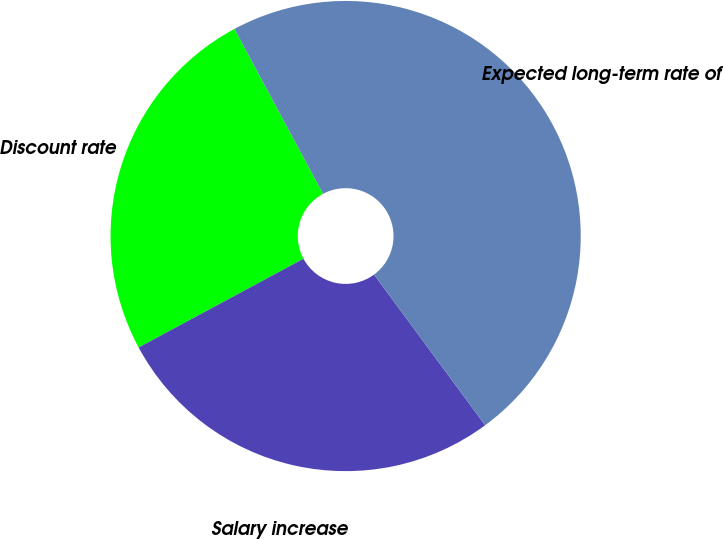Convert chart. <chart><loc_0><loc_0><loc_500><loc_500><pie_chart><fcel>Discount rate<fcel>Salary increase<fcel>Expected long-term rate of<nl><fcel>25.02%<fcel>27.25%<fcel>47.73%<nl></chart> 